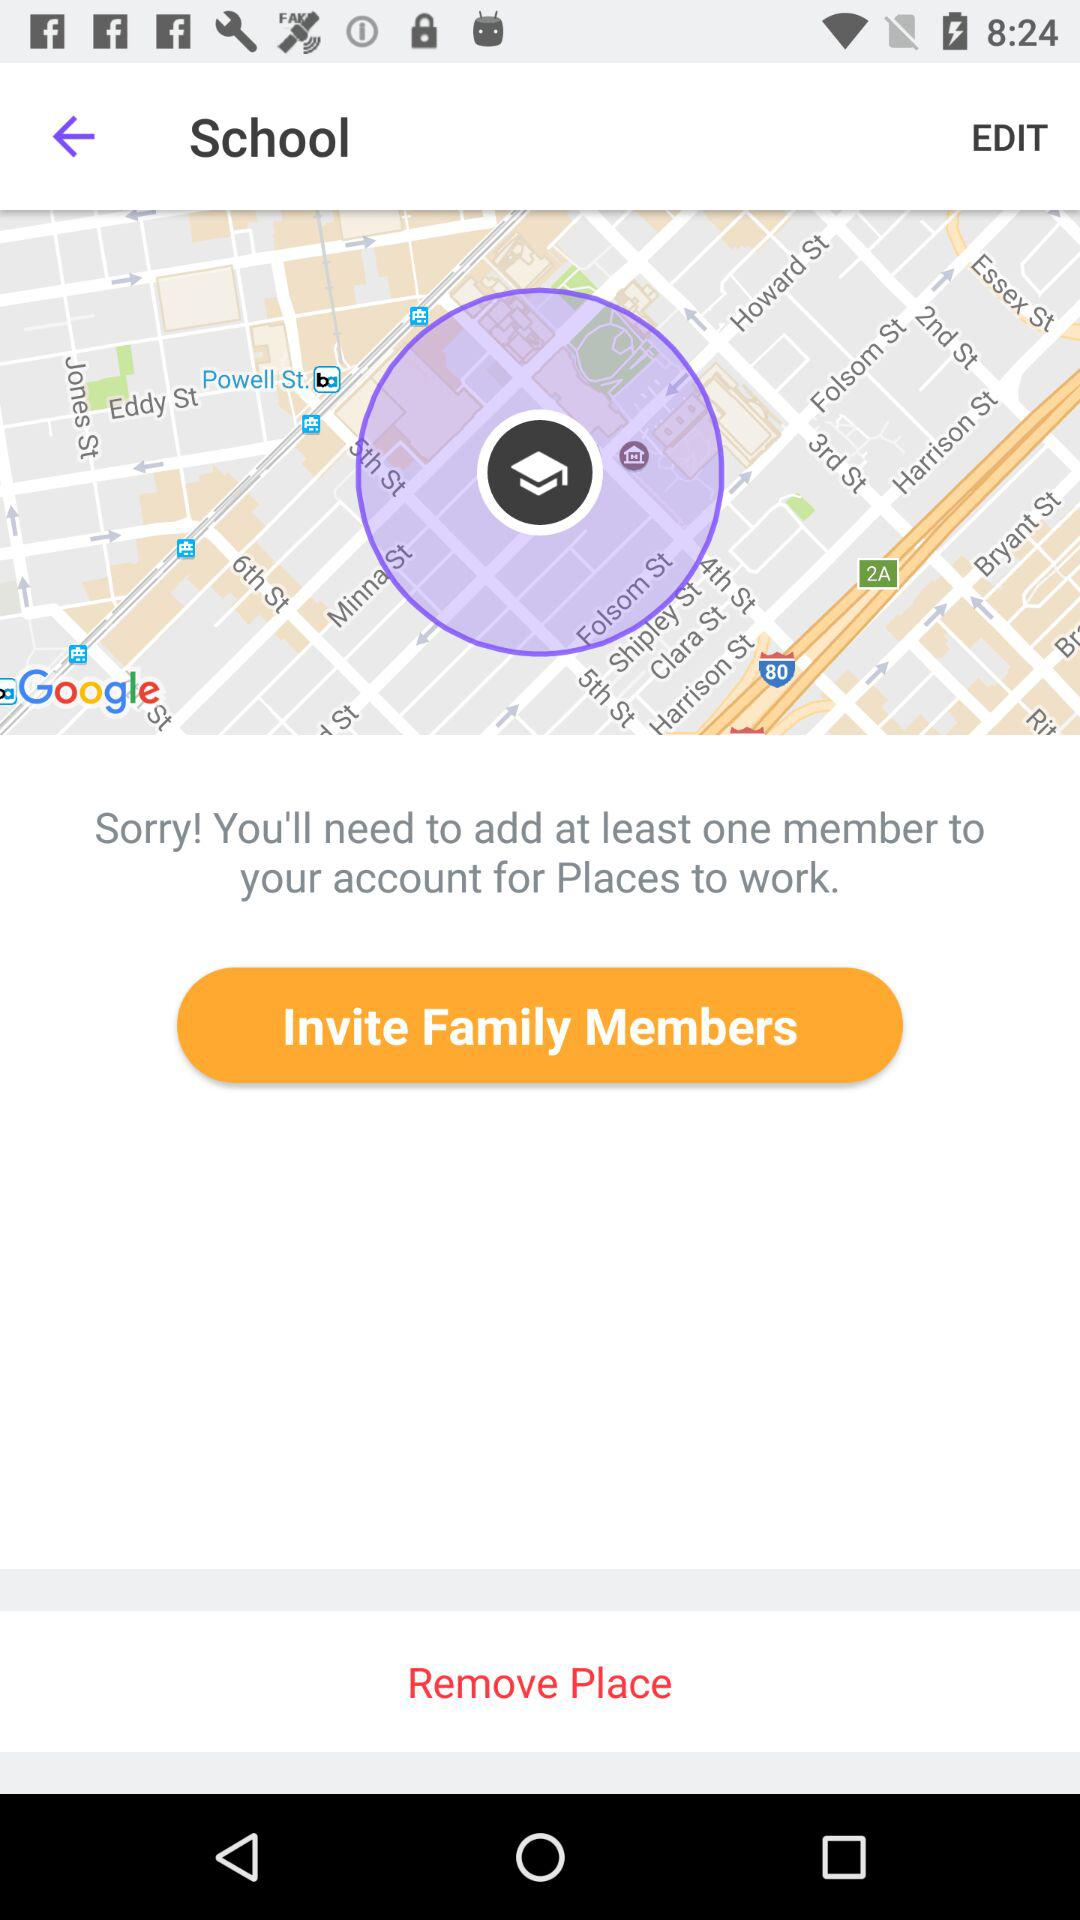How many members to add to the account for "Places to work"? There is at least one member to add to the account for "Places to work". 